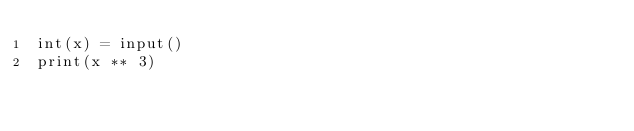<code> <loc_0><loc_0><loc_500><loc_500><_Python_>int(x) = input()
print(x ** 3)</code> 